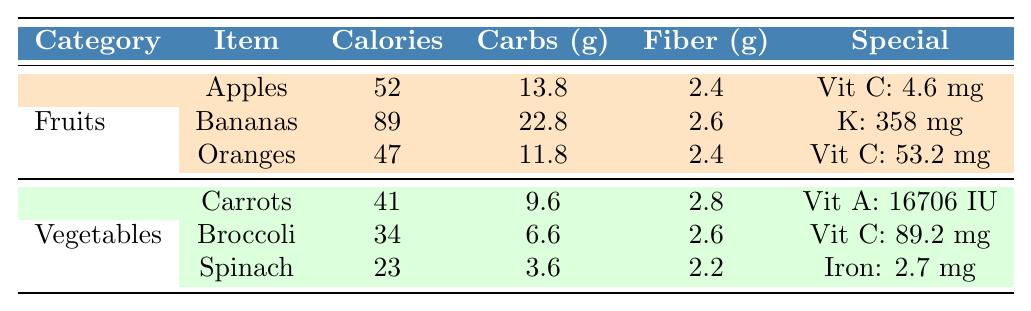What is the calorie content of Bananas? The calorie content for Bananas is listed in the table as 89 calories per 100g.
Answer: 89 calories Which contains more Vitamin C, Oranges or Apples? Looking at the table, Oranges have 53.2 mg of Vitamin C, while Apples have 4.6 mg. Therefore, Oranges contain more Vitamin C than Apples.
Answer: Oranges What is the total carbohydrate content of Carrots and Spinach? For Carrots, the carbohydrate content is 9.6 g and for Spinach, it is 3.6 g. Adding these together gives 9.6 + 3.6 = 13.2 g.
Answer: 13.2 g Does Broccoli have more fiber than Spinach? The table shows that Broccoli has 2.6 g of fiber while Spinach has 2.2 g. Since 2.6 g is greater than 2.2 g, Broccoli has more fiber than Spinach.
Answer: Yes What is the average carbohydrate content of the fruits listed? The carbohydrate contents are 13.8 g (Apples), 22.8 g (Bananas), and 11.8 g (Oranges). Summing these gives 13.8 + 22.8 + 11.8 = 48.4 g. Dividing by 3 (the number of fruits) gives an average of 48.4 / 3 = 16.13 g.
Answer: 16.13 g Which vegetable has the highest calorie content, and what is that value? The calories for each vegetable are 41 (Carrots), 34 (Broccoli), and 23 (Spinach). The highest value is 41 calories in Carrots.
Answer: Carrots, 41 calories How much more Vitamin A does Carrots have compared to Spinach? Carrots have 16706 IU of Vitamin A, and Spinach has none listed, which implies it has 0 IU. The difference is 16706 - 0 = 16706 IU.
Answer: 16706 IU If you combine the fiber content of all listed fruits, what is the total? The fiber contents are 2.4 g (Apples), 2.6 g (Bananas), and 2.4 g (Oranges). Adding these gives 2.4 + 2.6 + 2.4 = 7.4 g.
Answer: 7.4 g Which has less fiber, Broccoli or Carrots? Broccoli has 2.6 g of fiber and Carrots have 2.8 g. Since 2.6 g is less than 2.8 g, Broccoli has less fiber than Carrots.
Answer: Broccoli What is the total number of calories for all the fruits? The calories for each fruit are 52 (Apples), 89 (Bananas), and 47 (Oranges). Adding these gives 52 + 89 + 47 = 188 calories.
Answer: 188 calories 